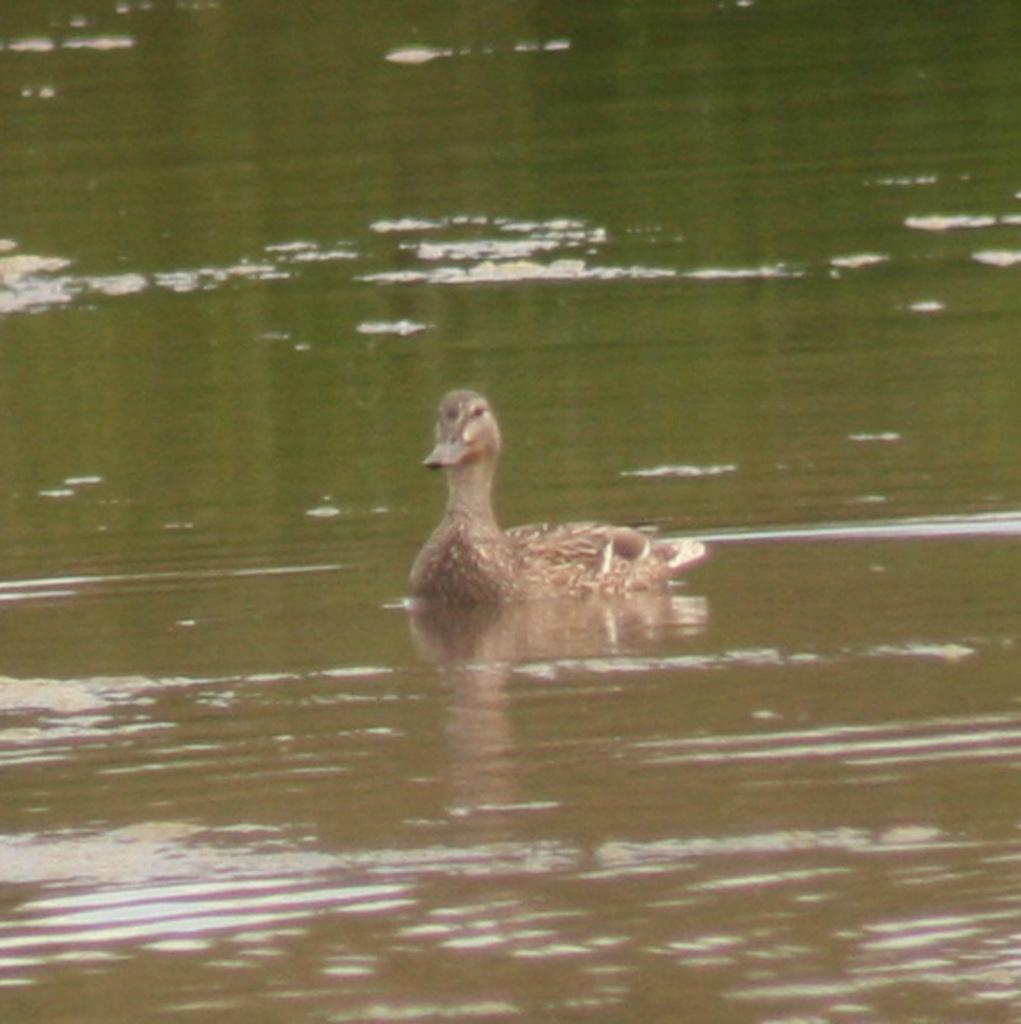What type of animal is in the image? There is a duck in the image. Where is the duck located in the image? The duck is on the water. What type of beast can be seen begging for food in the image? There is no beast present in the image, and the duck is not begging for food. 